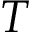Convert formula to latex. <formula><loc_0><loc_0><loc_500><loc_500>T</formula> 